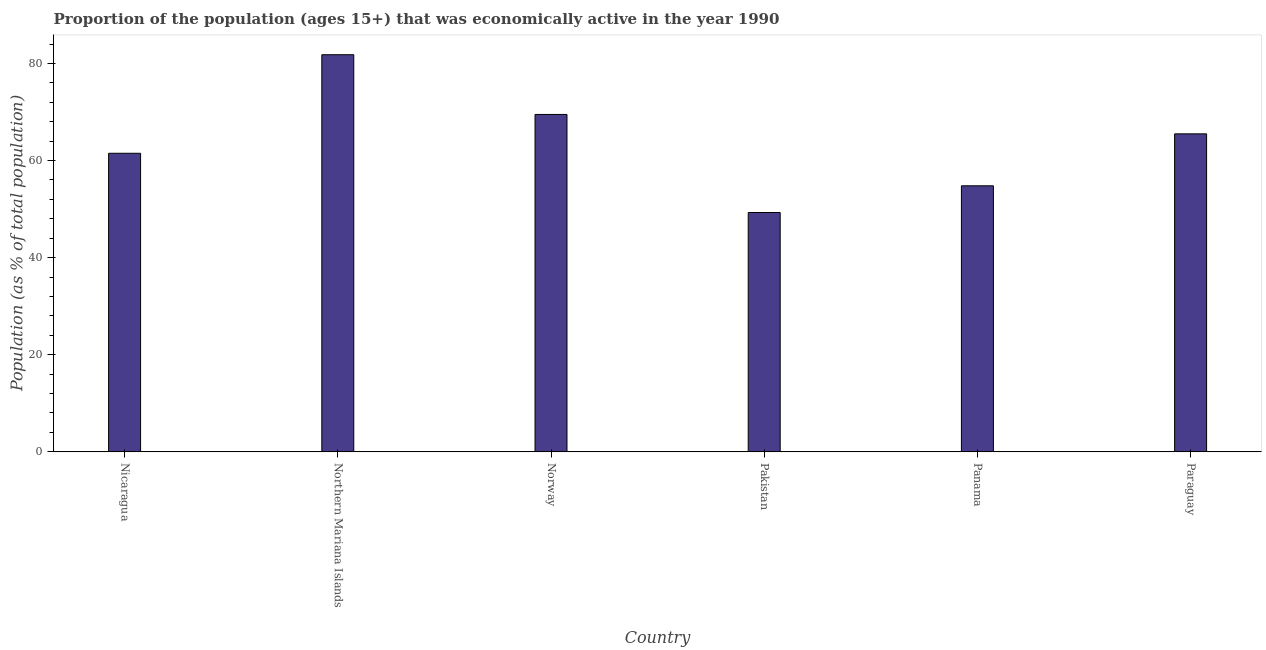What is the title of the graph?
Provide a short and direct response. Proportion of the population (ages 15+) that was economically active in the year 1990. What is the label or title of the Y-axis?
Provide a succinct answer. Population (as % of total population). What is the percentage of economically active population in Pakistan?
Your answer should be very brief. 49.3. Across all countries, what is the maximum percentage of economically active population?
Your answer should be very brief. 81.8. Across all countries, what is the minimum percentage of economically active population?
Your response must be concise. 49.3. In which country was the percentage of economically active population maximum?
Provide a succinct answer. Northern Mariana Islands. In which country was the percentage of economically active population minimum?
Provide a short and direct response. Pakistan. What is the sum of the percentage of economically active population?
Offer a very short reply. 382.4. What is the difference between the percentage of economically active population in Nicaragua and Northern Mariana Islands?
Offer a terse response. -20.3. What is the average percentage of economically active population per country?
Your response must be concise. 63.73. What is the median percentage of economically active population?
Ensure brevity in your answer.  63.5. What is the ratio of the percentage of economically active population in Northern Mariana Islands to that in Paraguay?
Offer a terse response. 1.25. Is the percentage of economically active population in Nicaragua less than that in Norway?
Make the answer very short. Yes. Is the difference between the percentage of economically active population in Pakistan and Panama greater than the difference between any two countries?
Provide a succinct answer. No. What is the difference between the highest and the second highest percentage of economically active population?
Provide a succinct answer. 12.3. Is the sum of the percentage of economically active population in Nicaragua and Norway greater than the maximum percentage of economically active population across all countries?
Your answer should be compact. Yes. What is the difference between the highest and the lowest percentage of economically active population?
Provide a succinct answer. 32.5. Are all the bars in the graph horizontal?
Offer a very short reply. No. What is the difference between two consecutive major ticks on the Y-axis?
Ensure brevity in your answer.  20. Are the values on the major ticks of Y-axis written in scientific E-notation?
Offer a very short reply. No. What is the Population (as % of total population) in Nicaragua?
Provide a short and direct response. 61.5. What is the Population (as % of total population) of Northern Mariana Islands?
Ensure brevity in your answer.  81.8. What is the Population (as % of total population) of Norway?
Keep it short and to the point. 69.5. What is the Population (as % of total population) in Pakistan?
Make the answer very short. 49.3. What is the Population (as % of total population) of Panama?
Provide a short and direct response. 54.8. What is the Population (as % of total population) in Paraguay?
Keep it short and to the point. 65.5. What is the difference between the Population (as % of total population) in Nicaragua and Northern Mariana Islands?
Make the answer very short. -20.3. What is the difference between the Population (as % of total population) in Nicaragua and Norway?
Keep it short and to the point. -8. What is the difference between the Population (as % of total population) in Nicaragua and Pakistan?
Make the answer very short. 12.2. What is the difference between the Population (as % of total population) in Nicaragua and Panama?
Offer a terse response. 6.7. What is the difference between the Population (as % of total population) in Nicaragua and Paraguay?
Ensure brevity in your answer.  -4. What is the difference between the Population (as % of total population) in Northern Mariana Islands and Pakistan?
Keep it short and to the point. 32.5. What is the difference between the Population (as % of total population) in Norway and Pakistan?
Keep it short and to the point. 20.2. What is the difference between the Population (as % of total population) in Norway and Panama?
Your answer should be very brief. 14.7. What is the difference between the Population (as % of total population) in Pakistan and Paraguay?
Offer a very short reply. -16.2. What is the ratio of the Population (as % of total population) in Nicaragua to that in Northern Mariana Islands?
Your response must be concise. 0.75. What is the ratio of the Population (as % of total population) in Nicaragua to that in Norway?
Ensure brevity in your answer.  0.89. What is the ratio of the Population (as % of total population) in Nicaragua to that in Pakistan?
Ensure brevity in your answer.  1.25. What is the ratio of the Population (as % of total population) in Nicaragua to that in Panama?
Make the answer very short. 1.12. What is the ratio of the Population (as % of total population) in Nicaragua to that in Paraguay?
Ensure brevity in your answer.  0.94. What is the ratio of the Population (as % of total population) in Northern Mariana Islands to that in Norway?
Make the answer very short. 1.18. What is the ratio of the Population (as % of total population) in Northern Mariana Islands to that in Pakistan?
Make the answer very short. 1.66. What is the ratio of the Population (as % of total population) in Northern Mariana Islands to that in Panama?
Make the answer very short. 1.49. What is the ratio of the Population (as % of total population) in Northern Mariana Islands to that in Paraguay?
Provide a short and direct response. 1.25. What is the ratio of the Population (as % of total population) in Norway to that in Pakistan?
Provide a succinct answer. 1.41. What is the ratio of the Population (as % of total population) in Norway to that in Panama?
Provide a short and direct response. 1.27. What is the ratio of the Population (as % of total population) in Norway to that in Paraguay?
Keep it short and to the point. 1.06. What is the ratio of the Population (as % of total population) in Pakistan to that in Paraguay?
Make the answer very short. 0.75. What is the ratio of the Population (as % of total population) in Panama to that in Paraguay?
Offer a terse response. 0.84. 